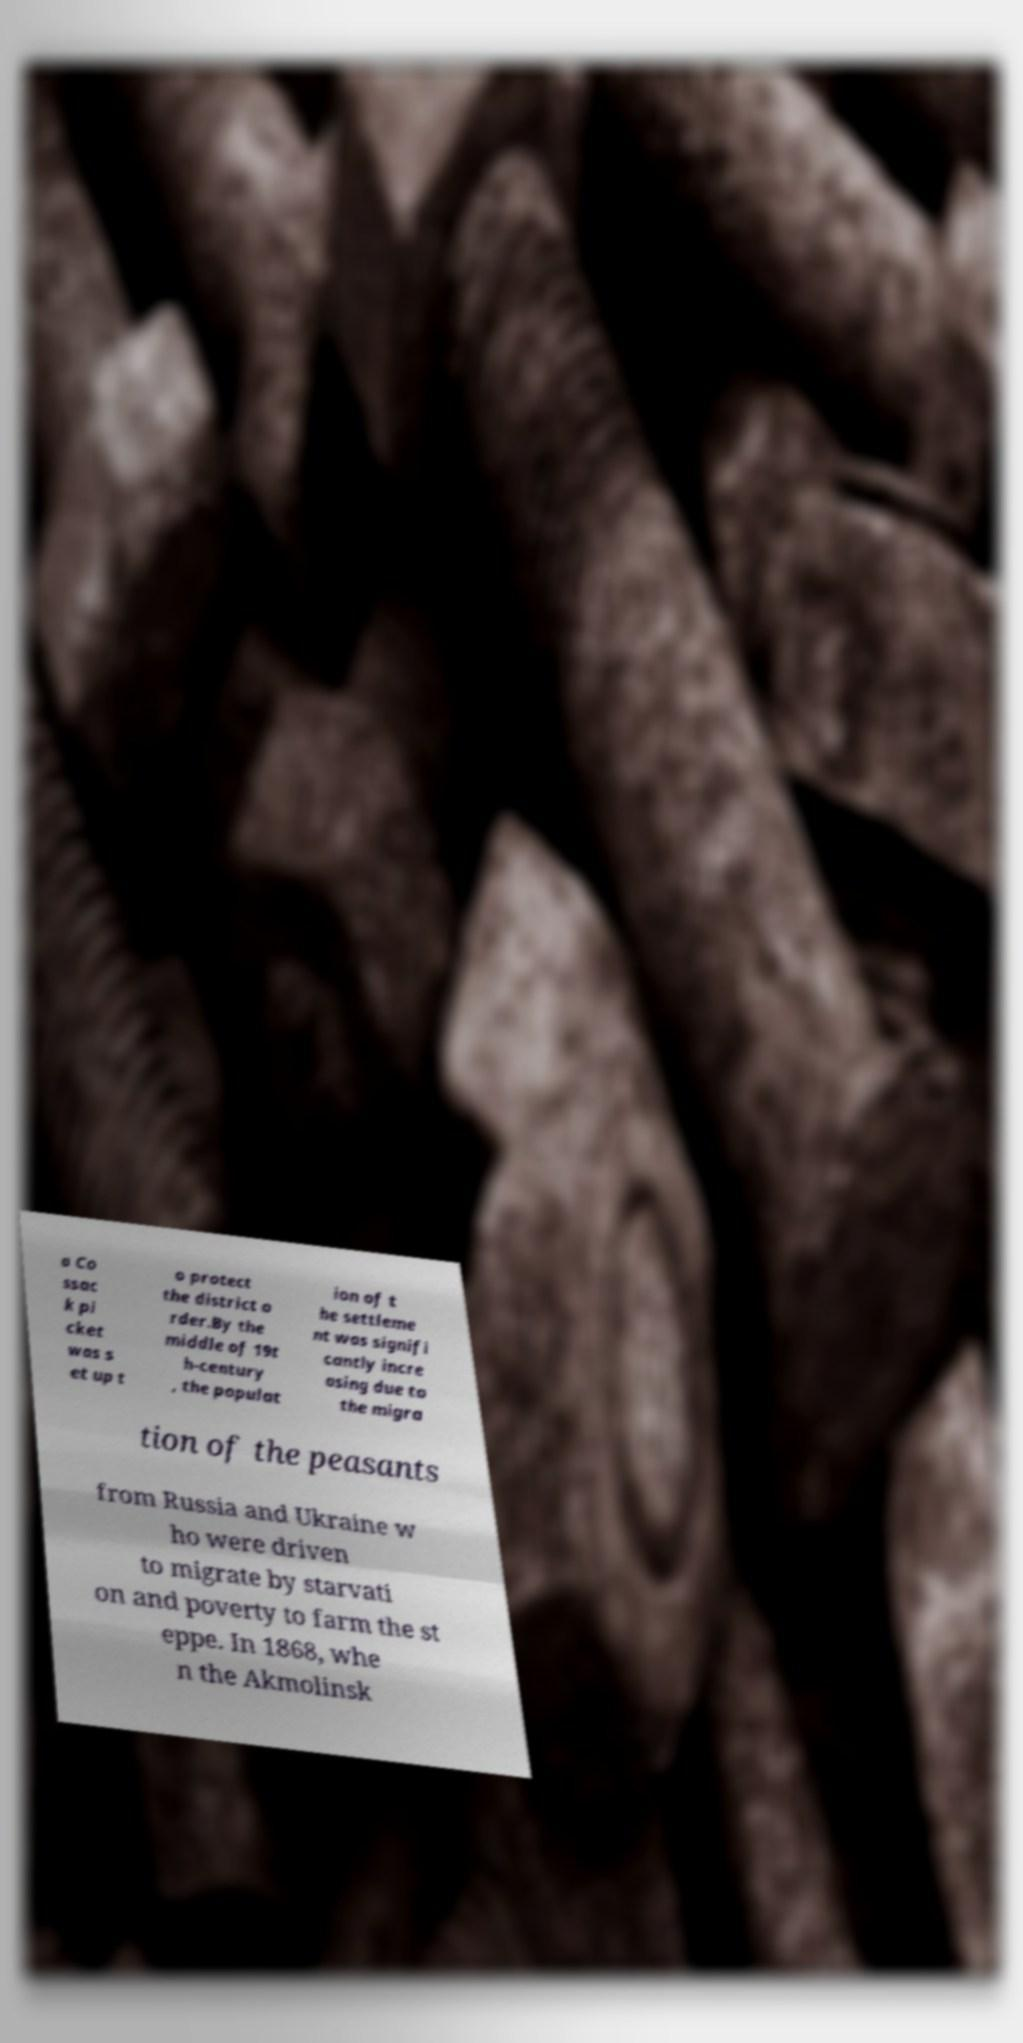Please read and relay the text visible in this image. What does it say? a Co ssac k pi cket was s et up t o protect the district o rder.By the middle of 19t h-century , the populat ion of t he settleme nt was signifi cantly incre asing due to the migra tion of the peasants from Russia and Ukraine w ho were driven to migrate by starvati on and poverty to farm the st eppe. In 1868, whe n the Akmolinsk 